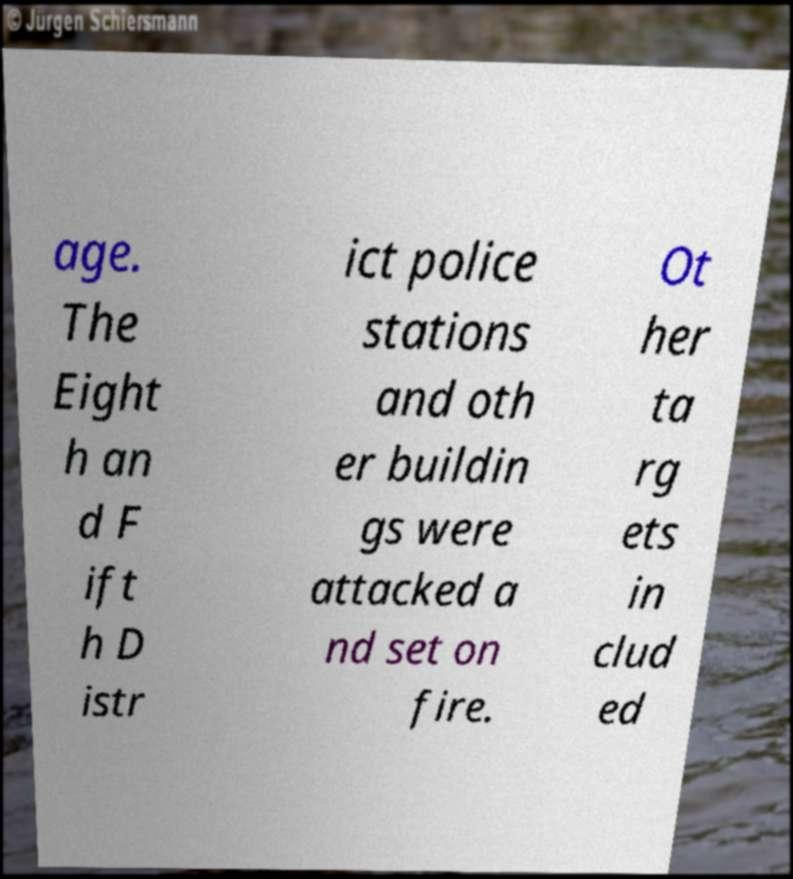For documentation purposes, I need the text within this image transcribed. Could you provide that? age. The Eight h an d F ift h D istr ict police stations and oth er buildin gs were attacked a nd set on fire. Ot her ta rg ets in clud ed 